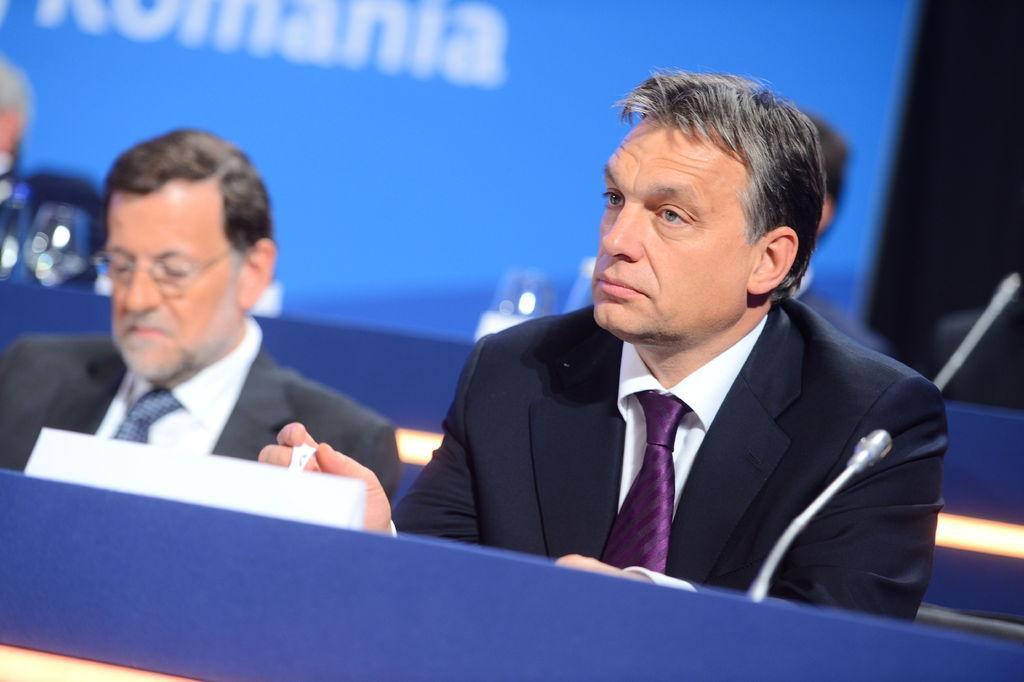Could you give a brief overview of what you see in this image? In this image, we can see a person in a suit is sitting and holding some object. Here we can see microphones, people, blue color objects and some objects. Background we can see blue color object and some text. 